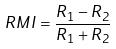<formula> <loc_0><loc_0><loc_500><loc_500>R M I = \frac { R _ { 1 } - R _ { 2 } } { R _ { 1 } + R _ { 2 } }</formula> 